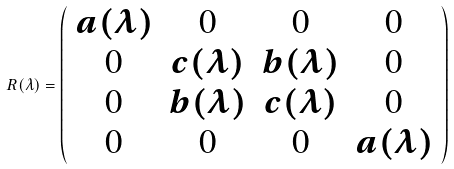Convert formula to latex. <formula><loc_0><loc_0><loc_500><loc_500>R ( \lambda ) = \left ( \begin{array} { c c c c } a ( \lambda ) & 0 & 0 & 0 \\ 0 & c ( \lambda ) & b ( \lambda ) & 0 \\ 0 & b ( \lambda ) & c ( \lambda ) & 0 \\ 0 & 0 & 0 & a ( \lambda ) \end{array} \right )</formula> 